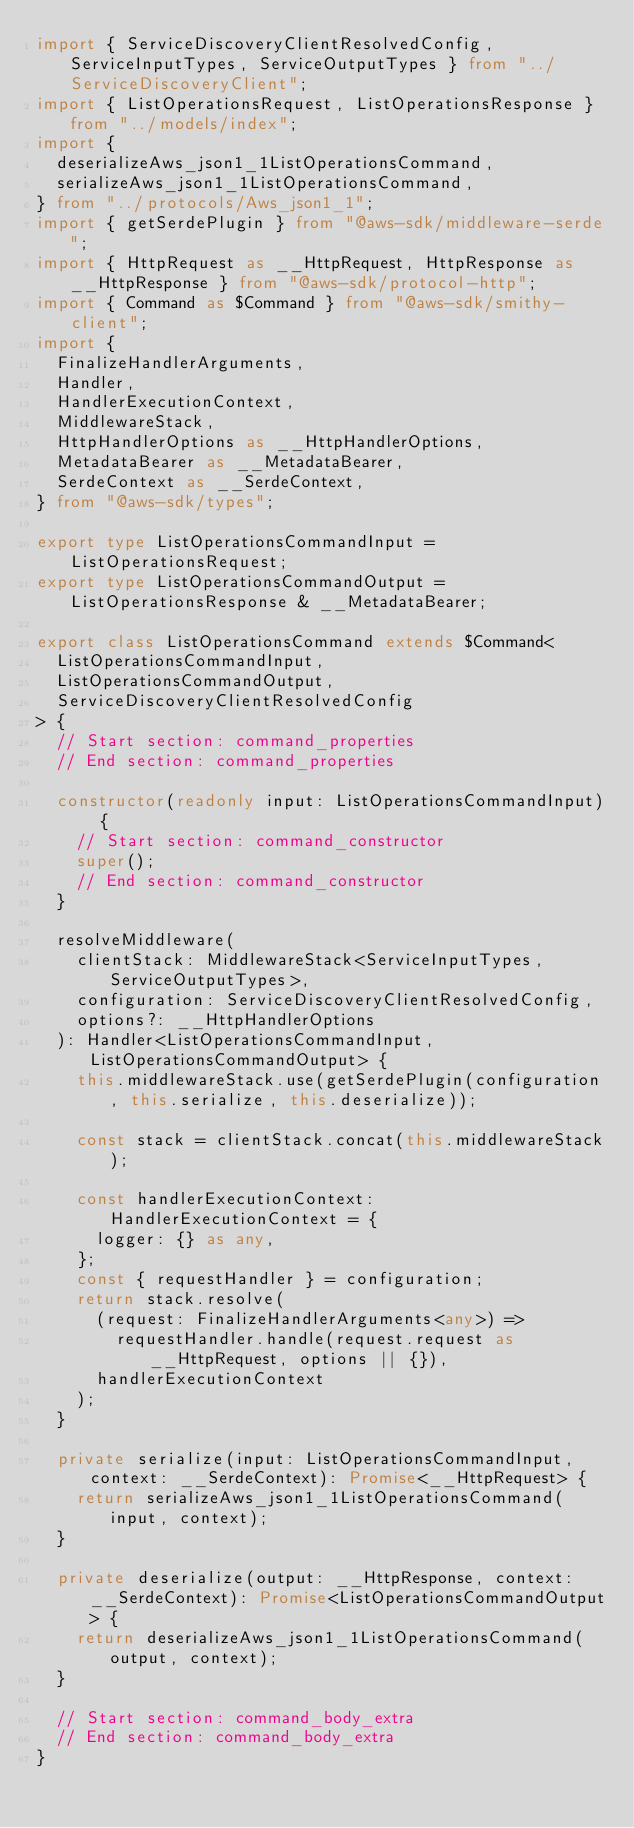<code> <loc_0><loc_0><loc_500><loc_500><_TypeScript_>import { ServiceDiscoveryClientResolvedConfig, ServiceInputTypes, ServiceOutputTypes } from "../ServiceDiscoveryClient";
import { ListOperationsRequest, ListOperationsResponse } from "../models/index";
import {
  deserializeAws_json1_1ListOperationsCommand,
  serializeAws_json1_1ListOperationsCommand,
} from "../protocols/Aws_json1_1";
import { getSerdePlugin } from "@aws-sdk/middleware-serde";
import { HttpRequest as __HttpRequest, HttpResponse as __HttpResponse } from "@aws-sdk/protocol-http";
import { Command as $Command } from "@aws-sdk/smithy-client";
import {
  FinalizeHandlerArguments,
  Handler,
  HandlerExecutionContext,
  MiddlewareStack,
  HttpHandlerOptions as __HttpHandlerOptions,
  MetadataBearer as __MetadataBearer,
  SerdeContext as __SerdeContext,
} from "@aws-sdk/types";

export type ListOperationsCommandInput = ListOperationsRequest;
export type ListOperationsCommandOutput = ListOperationsResponse & __MetadataBearer;

export class ListOperationsCommand extends $Command<
  ListOperationsCommandInput,
  ListOperationsCommandOutput,
  ServiceDiscoveryClientResolvedConfig
> {
  // Start section: command_properties
  // End section: command_properties

  constructor(readonly input: ListOperationsCommandInput) {
    // Start section: command_constructor
    super();
    // End section: command_constructor
  }

  resolveMiddleware(
    clientStack: MiddlewareStack<ServiceInputTypes, ServiceOutputTypes>,
    configuration: ServiceDiscoveryClientResolvedConfig,
    options?: __HttpHandlerOptions
  ): Handler<ListOperationsCommandInput, ListOperationsCommandOutput> {
    this.middlewareStack.use(getSerdePlugin(configuration, this.serialize, this.deserialize));

    const stack = clientStack.concat(this.middlewareStack);

    const handlerExecutionContext: HandlerExecutionContext = {
      logger: {} as any,
    };
    const { requestHandler } = configuration;
    return stack.resolve(
      (request: FinalizeHandlerArguments<any>) =>
        requestHandler.handle(request.request as __HttpRequest, options || {}),
      handlerExecutionContext
    );
  }

  private serialize(input: ListOperationsCommandInput, context: __SerdeContext): Promise<__HttpRequest> {
    return serializeAws_json1_1ListOperationsCommand(input, context);
  }

  private deserialize(output: __HttpResponse, context: __SerdeContext): Promise<ListOperationsCommandOutput> {
    return deserializeAws_json1_1ListOperationsCommand(output, context);
  }

  // Start section: command_body_extra
  // End section: command_body_extra
}
</code> 